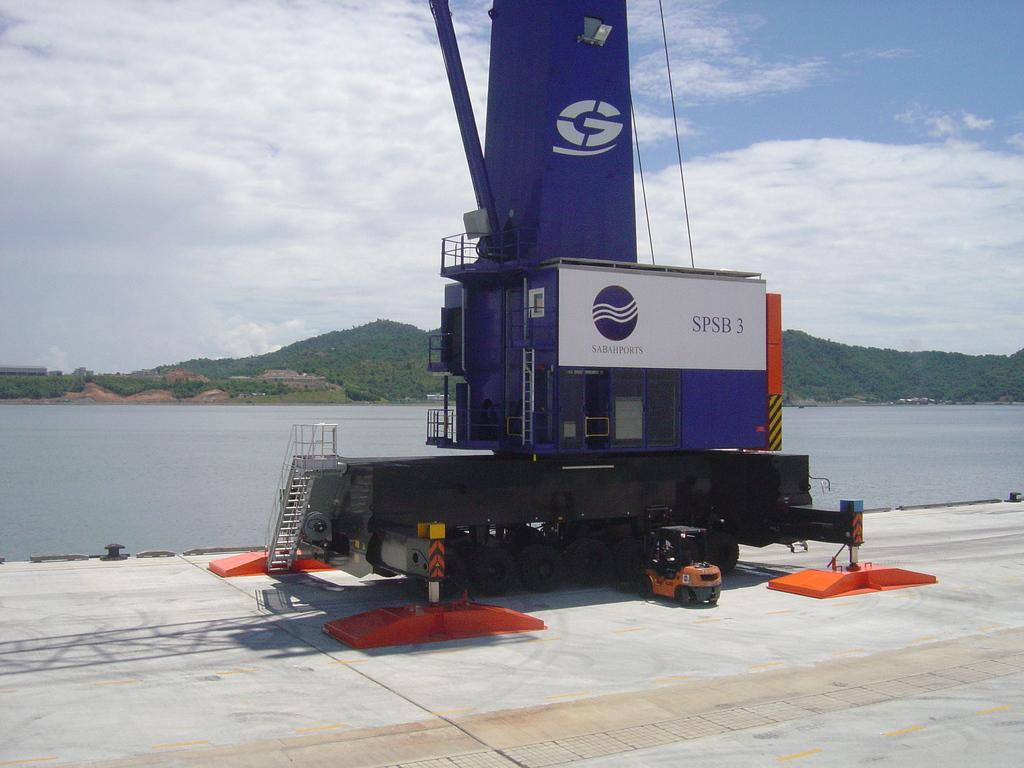What type of vehicle is on the road in the image? There is a crane on the road in the image. What can be seen in the distance behind the crane? There are mountains and water visible in the background of the image. What is visible in the sky in the image? The sky is visible in the background of the image, and there are clouds present. What type of button is being used to add more fiction to the image? There is no button or fiction present in the image; it is a realistic scene featuring a crane on the road with mountains, water, and clouds in the background. 